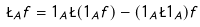<formula> <loc_0><loc_0><loc_500><loc_500>\L _ { A } f = 1 _ { A } \L ( 1 _ { A } f ) - ( 1 _ { A } \L 1 _ { A } ) f</formula> 